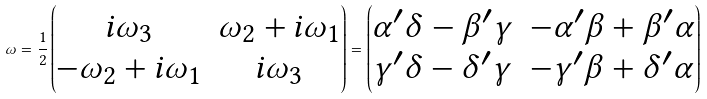Convert formula to latex. <formula><loc_0><loc_0><loc_500><loc_500>\omega = \frac { 1 } { 2 } \begin{pmatrix} i \omega _ { 3 } & \omega _ { 2 } + i \omega _ { 1 } \\ - \omega _ { 2 } + i \omega _ { 1 } & i \omega _ { 3 } \end{pmatrix} = \begin{pmatrix} \alpha ^ { \prime } \delta - \beta ^ { \prime } \gamma & - \alpha ^ { \prime } \beta + \beta ^ { \prime } \alpha \\ \gamma ^ { \prime } \delta - \delta ^ { \prime } \gamma & - \gamma ^ { \prime } \beta + \delta ^ { \prime } \alpha \end{pmatrix}</formula> 